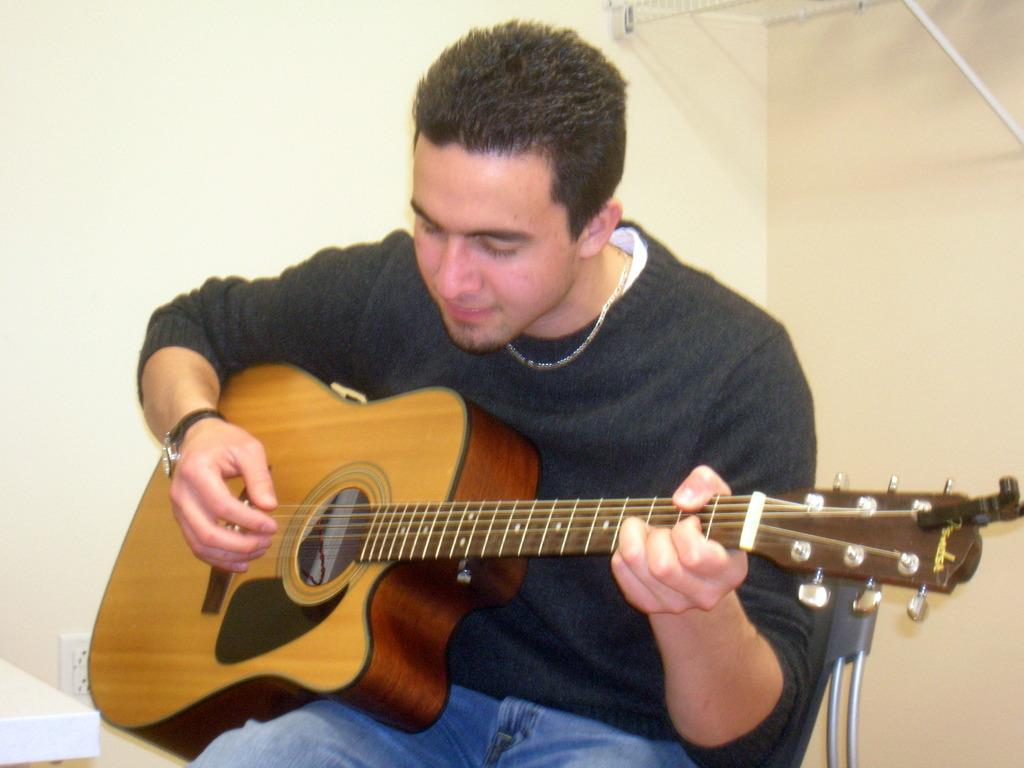What is the main subject of the image? The main subject of the image is a man. What is the man doing in the image? The man is sitting on a chair and playing the guitar. Can you describe the man's attire in the image? The man is wearing a watch on his right side. What is the background of the image? The background of the image is a white wall. How many robins can be seen perched on the horse in the image? There are no robins or horses present in the image; it features a man sitting on a chair and playing the guitar in front of a white wall. 